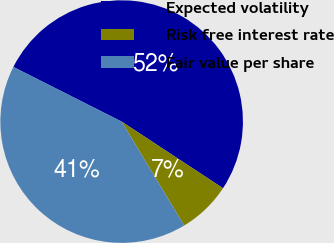Convert chart. <chart><loc_0><loc_0><loc_500><loc_500><pie_chart><fcel>Expected volatility<fcel>Risk free interest rate<fcel>Fair value per share<nl><fcel>51.82%<fcel>7.12%<fcel>41.06%<nl></chart> 